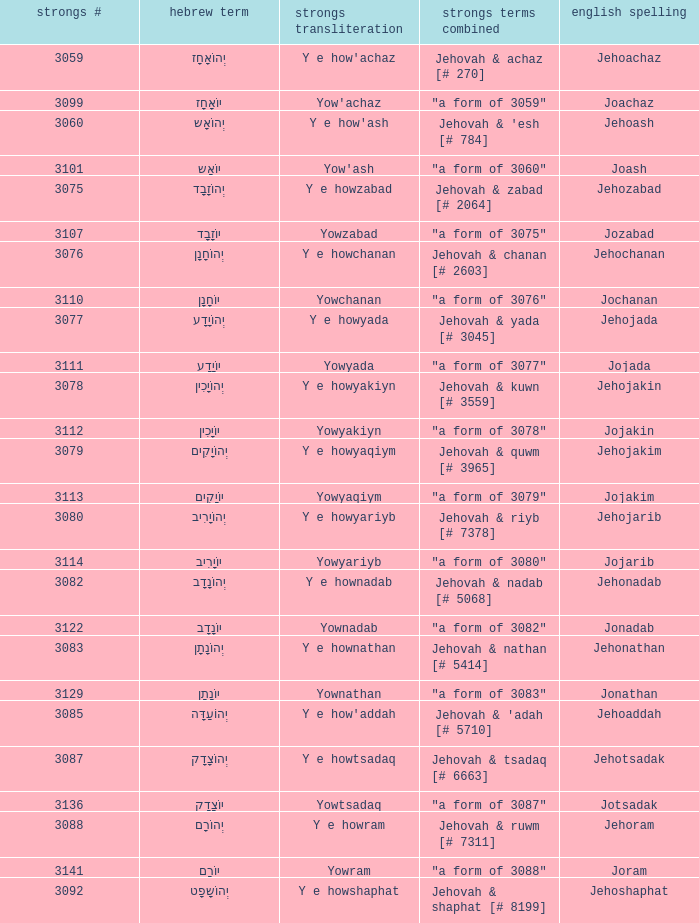What is the strongs transliteration of the hebrew word יוֹחָנָן? Yowchanan. 